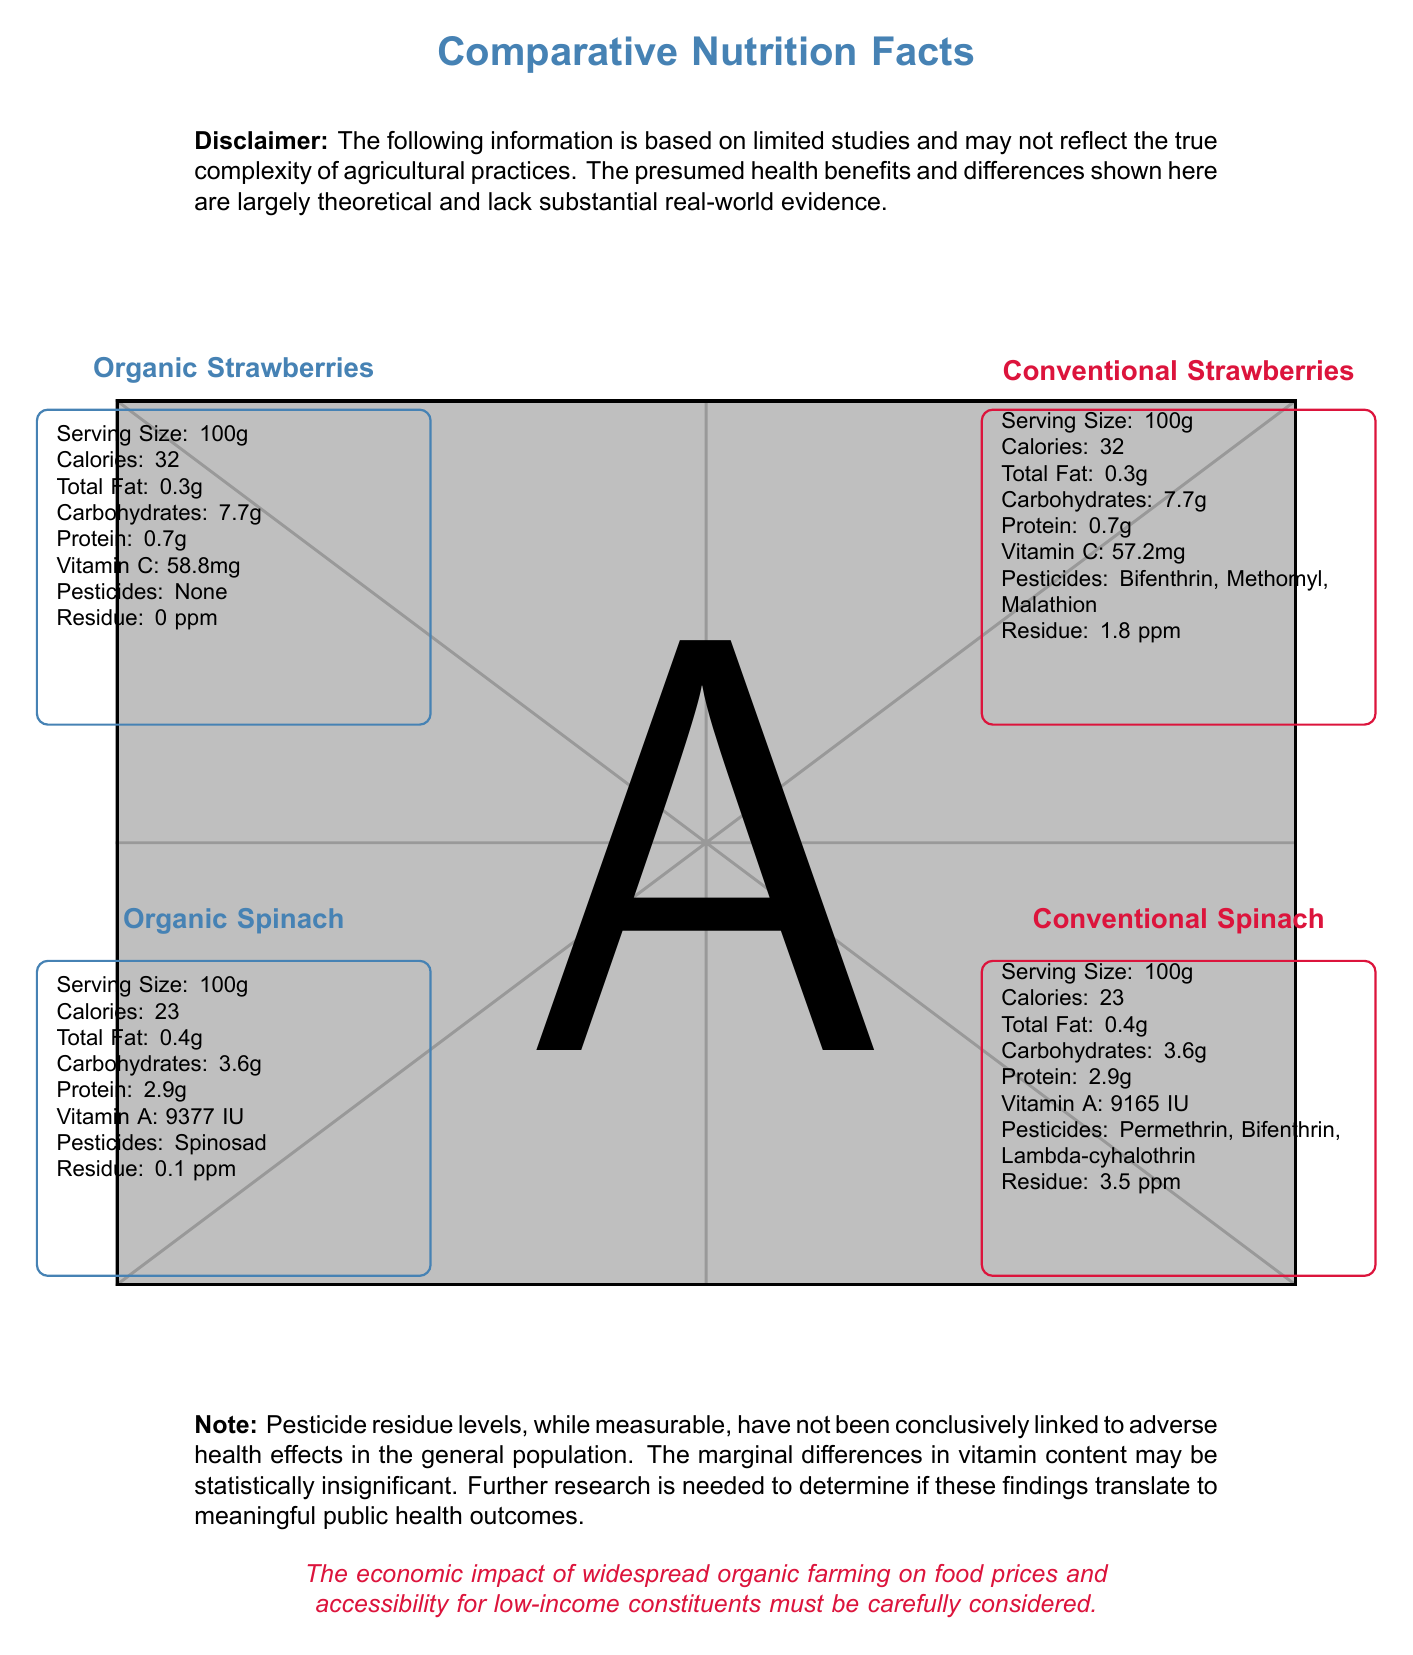what is the Vitamin C content in Organic Strawberries? The Vitamin C content for Organic Strawberries is listed as 58.8 mg in the document.
Answer: 58.8 mg what is the pesticide residue level in Conventional Spinach? The pesticide residue level for Conventional Spinach is noted as 3.5 ppm in the document.
Answer: 3.5 ppm which type of Strawberries has more pesticides detected? Conventional Strawberries have three pesticides detected (Bifenthrin, Methomyl, Malathion) compared to zero in Organic Strawberries.
Answer: Conventional Strawberries how does the Vitamin A content compare between Organic Spinach and Conventional Spinach? Organic Spinach contains 9377 IU of Vitamin A, while Conventional Spinach has 9165 IU.
Answer: Organic Spinach has slightly more Vitamin A are there any pesticides detected in Organic Strawberries? The document states that there are no pesticides detected in Organic Strawberries.
Answer: No which type of produce typically shows a lower pesticide residue level: organic or conventional? A. Organic B. Conventional C. Both D. None The document shows that organic produce generally has lower pesticide residue levels compared to conventional produce.
Answer: A. Organic how many pesticides are detected in Conventional Spinach? 1. One 2. Two 3. Three 4. Four Three pesticides (Permethrin, Bifenthrin, Lambda-cyhalothrin) are detected in Conventional Spinach as listed in the document.
Answer: 3. Three is the economic impact of widespread organic farming on food prices discussed in the document? The document includes a note about the economic impact of widespread organic farming on food prices and accessibility for low-income constituents.
Answer: Yes is there a significant difference in caloric content between conventional and organic produce of the same type? Both the organic and conventional strawberries have 32 calories per 100g, and both the organic and conventional spinach have 23 calories per 100g, indicating no significant difference.
Answer: No summarize the findings related to pesticide residues and vitamin content in the document. Organic Strawberries have no pesticide residues while Conventional Strawberries have three pesticides detected. Organic Spinach has one detectable pesticide with lower residue levels compared to the higher levels in Conventional Spinach. Additionally, the differences in vitamin content (Vitamin C in strawberries and Vitamin A in spinach) between organic and conventional are marginal.
Answer: The document compares organic and conventional produce, highlighting that organic produce, such as strawberries and spinach, generally has lower pesticide residue levels. Organic strawberries show slightly higher Vitamin C levels, and organic spinach has marginally more Vitamin A compared to their conventional counterparts. Nonetheless, the document notes that the real-world implications of these differences and economic impact need further research. which agricultural practices lead to better health outcomes? The document notes the need for further research to determine if these laboratory findings translate to meaningful public health outcomes.
Answer: Not enough information 